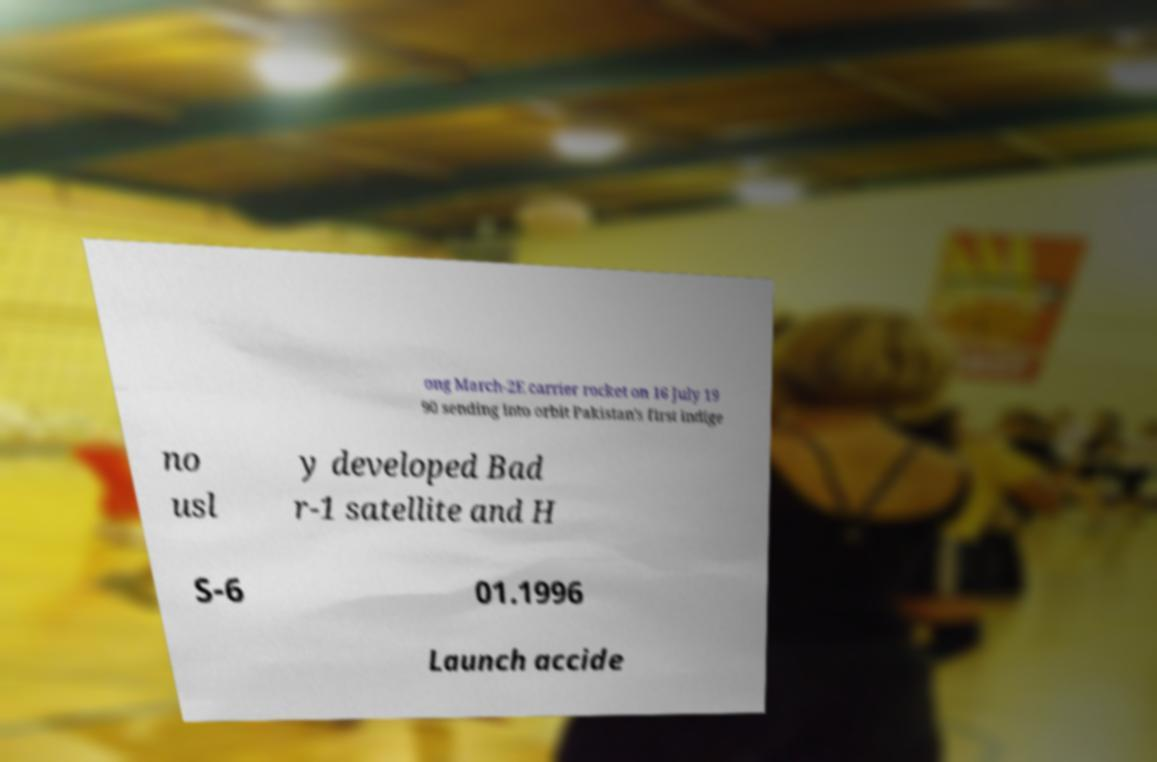Could you extract and type out the text from this image? ong March-2E carrier rocket on 16 July 19 90 sending into orbit Pakistan's first indige no usl y developed Bad r-1 satellite and H S-6 01.1996 Launch accide 